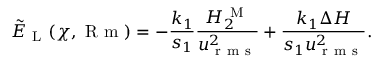Convert formula to latex. <formula><loc_0><loc_0><loc_500><loc_500>\tilde { E } _ { L } ( \chi , R m ) = - \frac { k _ { 1 } } { s _ { 1 } } \frac { H _ { 2 } ^ { M } } { u _ { r m s } ^ { 2 } } + \frac { k _ { 1 } \Delta H } { s _ { 1 } u _ { r m s } ^ { 2 } } .</formula> 